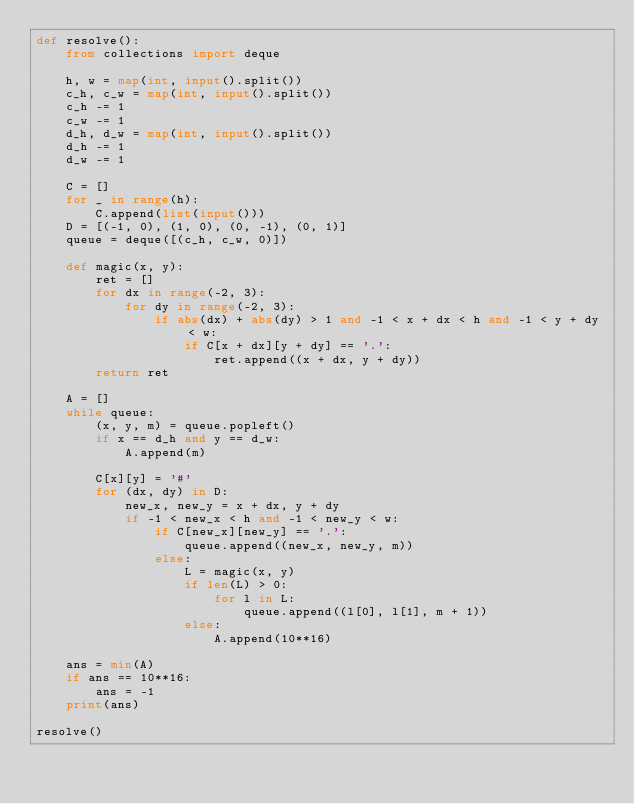Convert code to text. <code><loc_0><loc_0><loc_500><loc_500><_Python_>def resolve():
    from collections import deque

    h, w = map(int, input().split())
    c_h, c_w = map(int, input().split())
    c_h -= 1
    c_w -= 1
    d_h, d_w = map(int, input().split())
    d_h -= 1
    d_w -= 1

    C = []
    for _ in range(h):
        C.append(list(input()))
    D = [(-1, 0), (1, 0), (0, -1), (0, 1)]
    queue = deque([(c_h, c_w, 0)])

    def magic(x, y):
        ret = []
        for dx in range(-2, 3):
            for dy in range(-2, 3):
                if abs(dx) + abs(dy) > 1 and -1 < x + dx < h and -1 < y + dy < w:
                    if C[x + dx][y + dy] == '.':
                        ret.append((x + dx, y + dy))
        return ret

    A = []
    while queue:
        (x, y, m) = queue.popleft()
        if x == d_h and y == d_w:
            A.append(m)

        C[x][y] = '#'
        for (dx, dy) in D:
            new_x, new_y = x + dx, y + dy
            if -1 < new_x < h and -1 < new_y < w:
                if C[new_x][new_y] == '.':
                    queue.append((new_x, new_y, m))
                else:
                    L = magic(x, y)
                    if len(L) > 0:
                        for l in L:
                            queue.append((l[0], l[1], m + 1))
                    else:
                        A.append(10**16)

    ans = min(A)
    if ans == 10**16:
        ans = -1
    print(ans)
    
resolve()</code> 